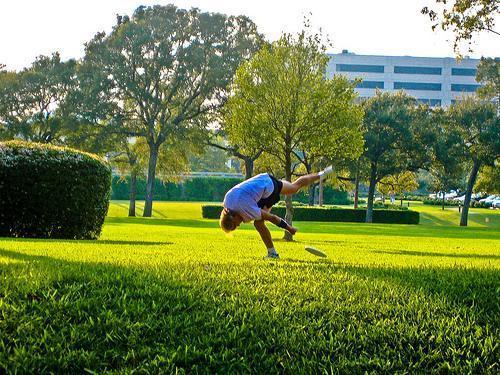How many feet are on the ground?
Give a very brief answer. 1. How many people are there?
Give a very brief answer. 1. 